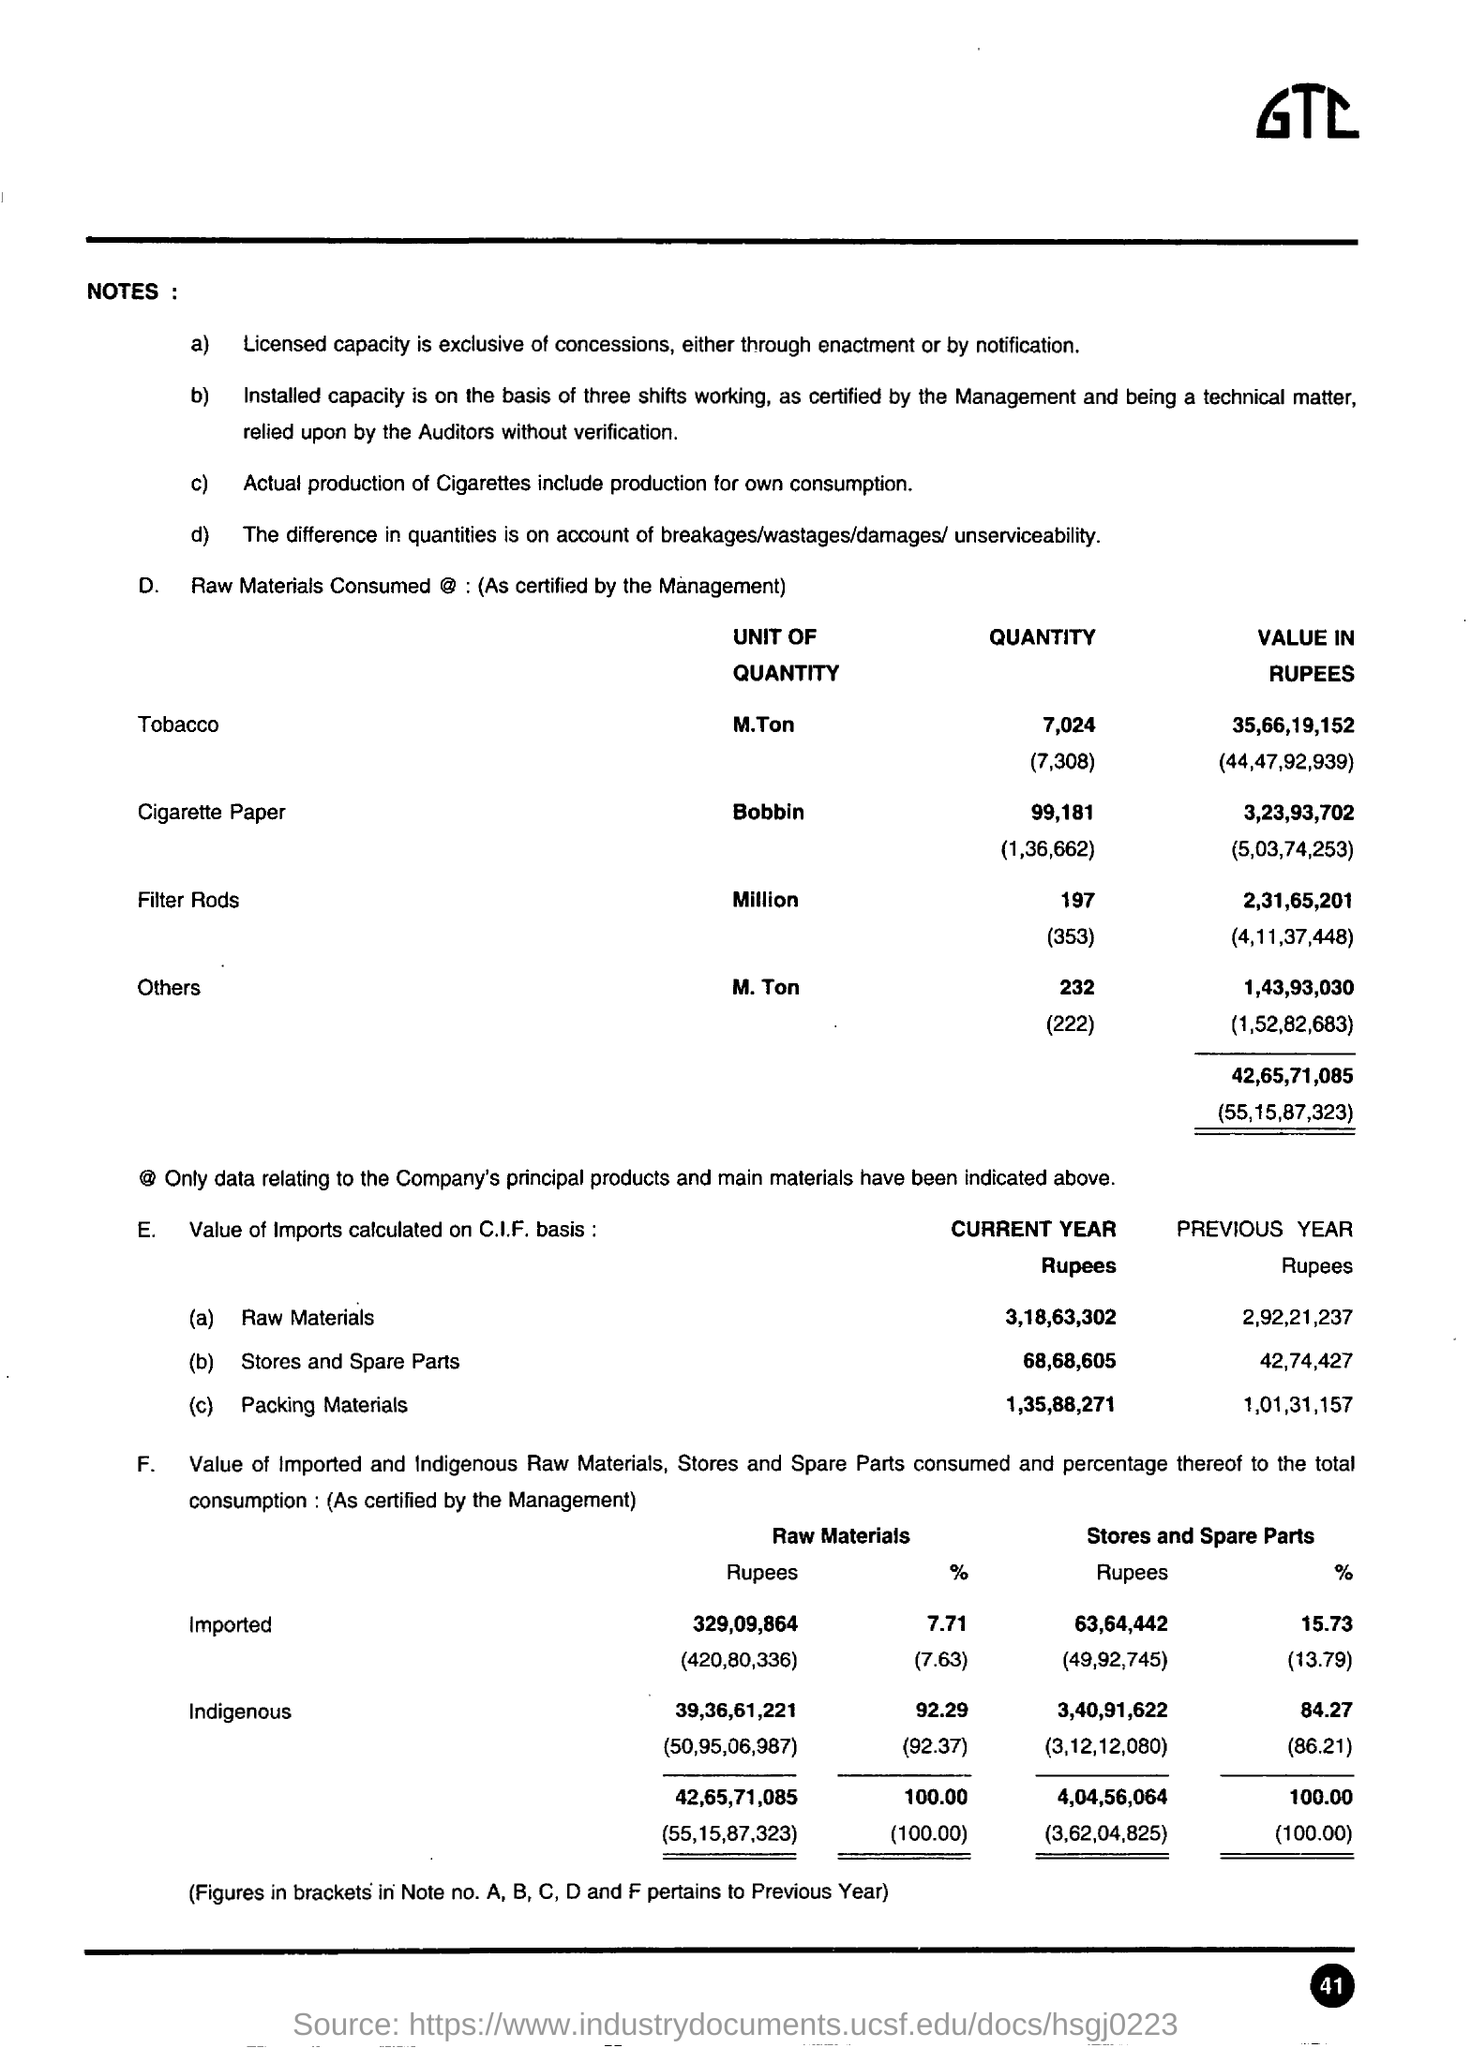List a handful of essential elements in this visual. The unit of quantity for cigarette paper is the bobbin. In the previous year, the percentage value of indigenous raw materials used was 92.37%. The percentage value of indigenous stores and spare parts in the previous year was 86.21%. 